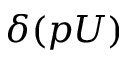Convert formula to latex. <formula><loc_0><loc_0><loc_500><loc_500>\delta ( p U )</formula> 